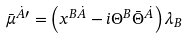<formula> <loc_0><loc_0><loc_500><loc_500>\bar { \mu } ^ { \dot { A } \prime } = \left ( x ^ { B \dot { A } } - i \Theta ^ { B } \bar { \Theta } ^ { \dot { A } } \right ) \lambda _ { B }</formula> 